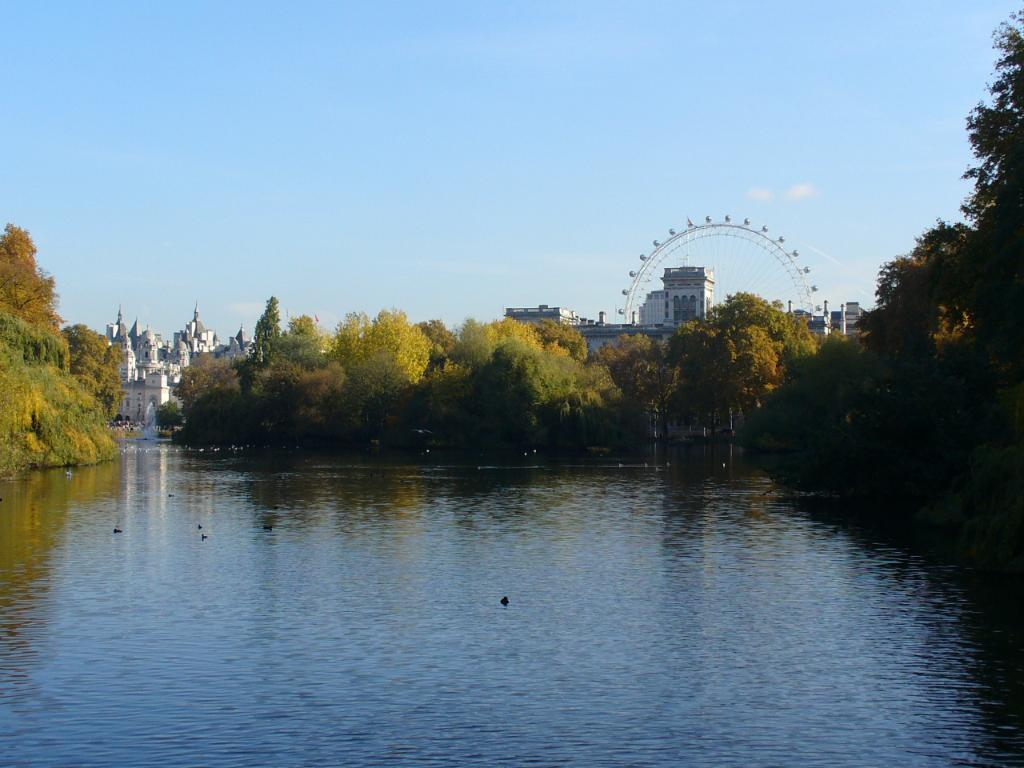What type of structures can be seen in the image? There are buildings in the image. What other natural elements are present in the image? There are trees in the image. Can you describe the object that resembles a wheel in the image? Yes, there is a joint wheel in the image. What is visible at the top of the image? The sky is visible at the top of the image. What animals can be seen near the water in the image? Birds are on the water at the bottom of the image. What hobbies does the dad have in the image? There is no dad or hobbies mentioned in the image. How many pigs are visible in the image? There are no pigs present in the image. 